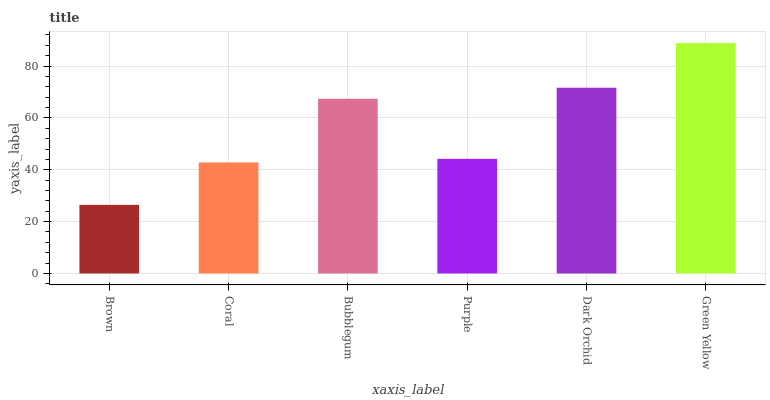Is Coral the minimum?
Answer yes or no. No. Is Coral the maximum?
Answer yes or no. No. Is Coral greater than Brown?
Answer yes or no. Yes. Is Brown less than Coral?
Answer yes or no. Yes. Is Brown greater than Coral?
Answer yes or no. No. Is Coral less than Brown?
Answer yes or no. No. Is Bubblegum the high median?
Answer yes or no. Yes. Is Purple the low median?
Answer yes or no. Yes. Is Coral the high median?
Answer yes or no. No. Is Green Yellow the low median?
Answer yes or no. No. 